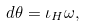Convert formula to latex. <formula><loc_0><loc_0><loc_500><loc_500>d \theta = \iota _ { H } \omega ,</formula> 